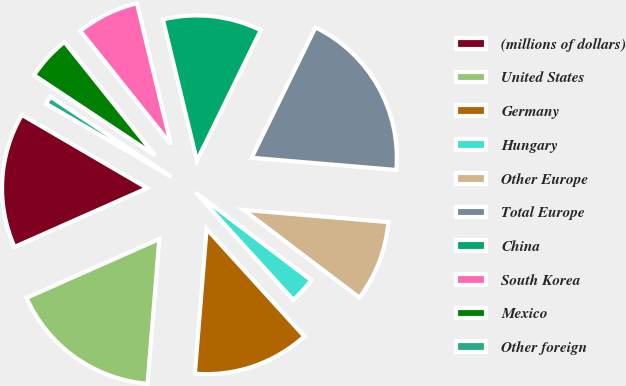<chart> <loc_0><loc_0><loc_500><loc_500><pie_chart><fcel>(millions of dollars)<fcel>United States<fcel>Germany<fcel>Hungary<fcel>Other Europe<fcel>Total Europe<fcel>China<fcel>South Korea<fcel>Mexico<fcel>Other foreign<nl><fcel>15.05%<fcel>17.07%<fcel>13.03%<fcel>2.93%<fcel>8.99%<fcel>19.09%<fcel>11.01%<fcel>6.97%<fcel>4.95%<fcel>0.91%<nl></chart> 